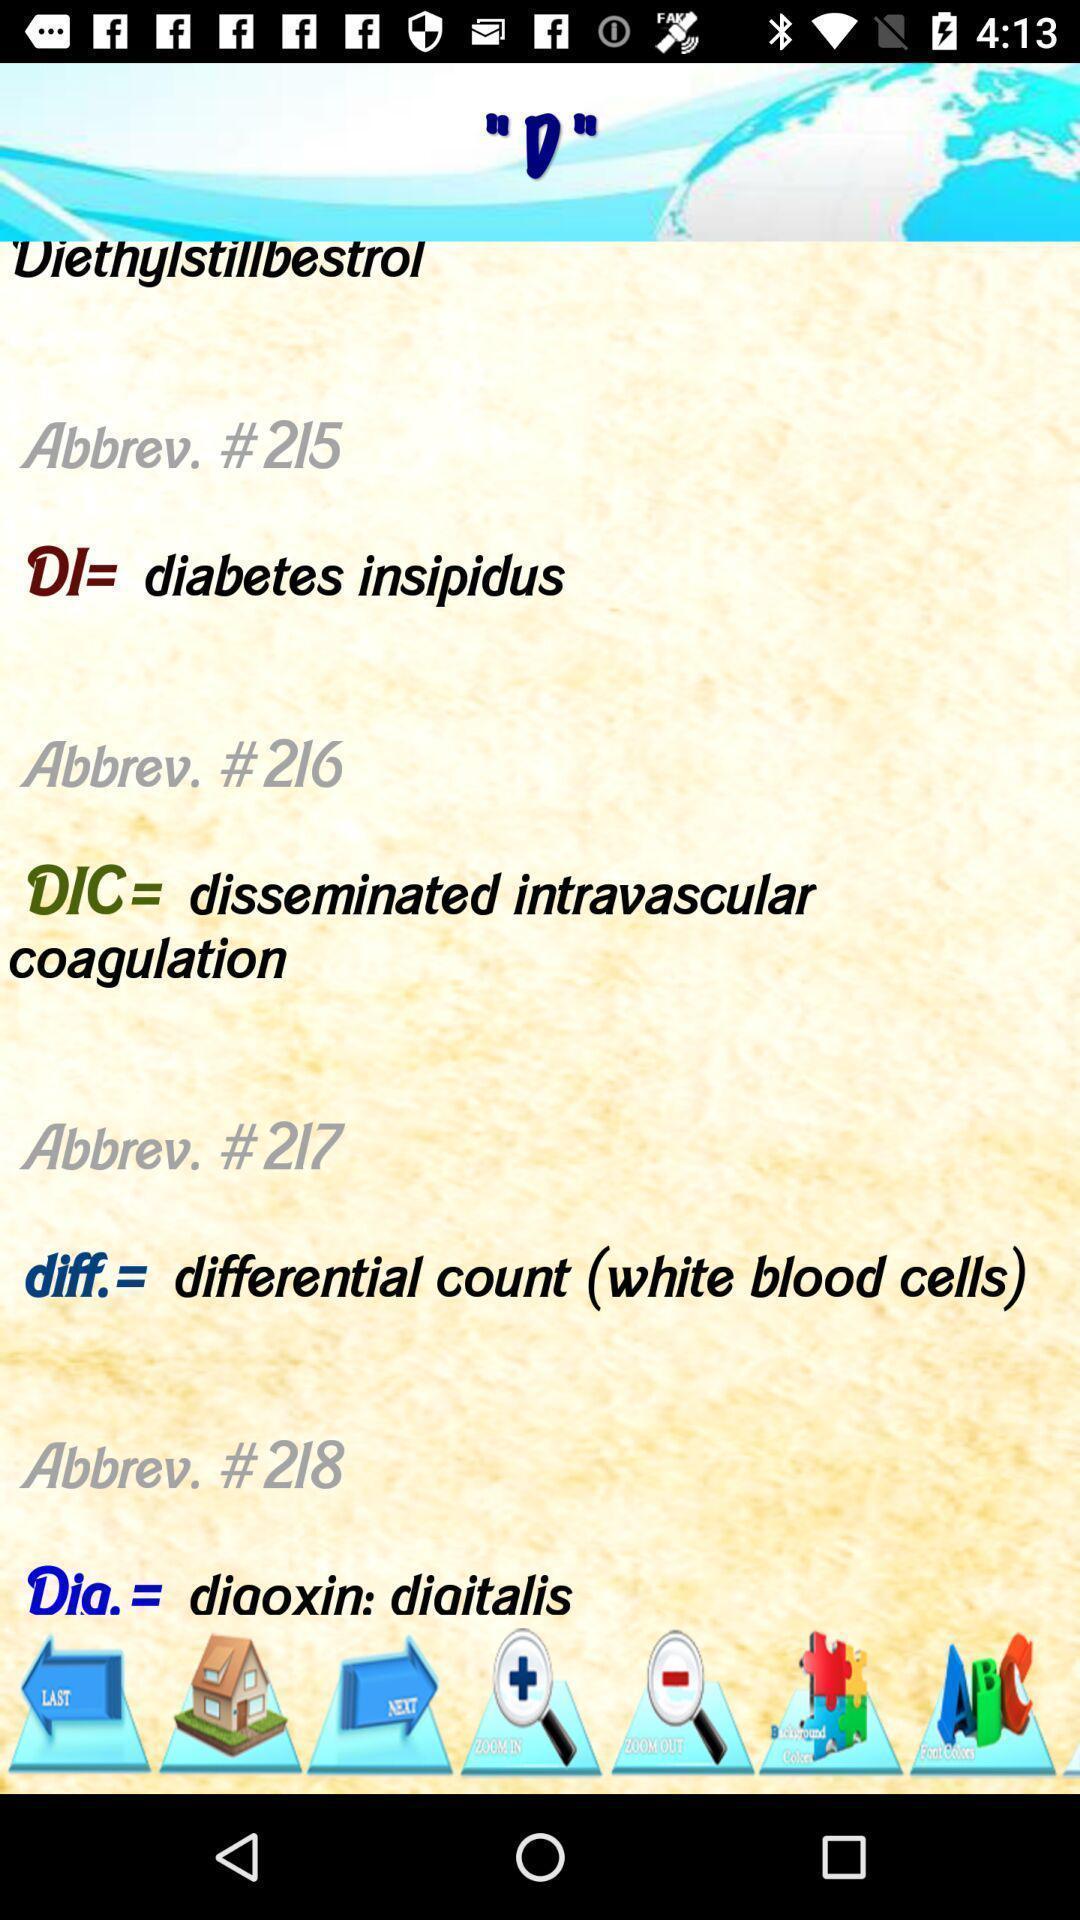Describe the visual elements of this screenshot. Page showing the abbreviation of different words. 